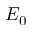Convert formula to latex. <formula><loc_0><loc_0><loc_500><loc_500>E _ { 0 }</formula> 